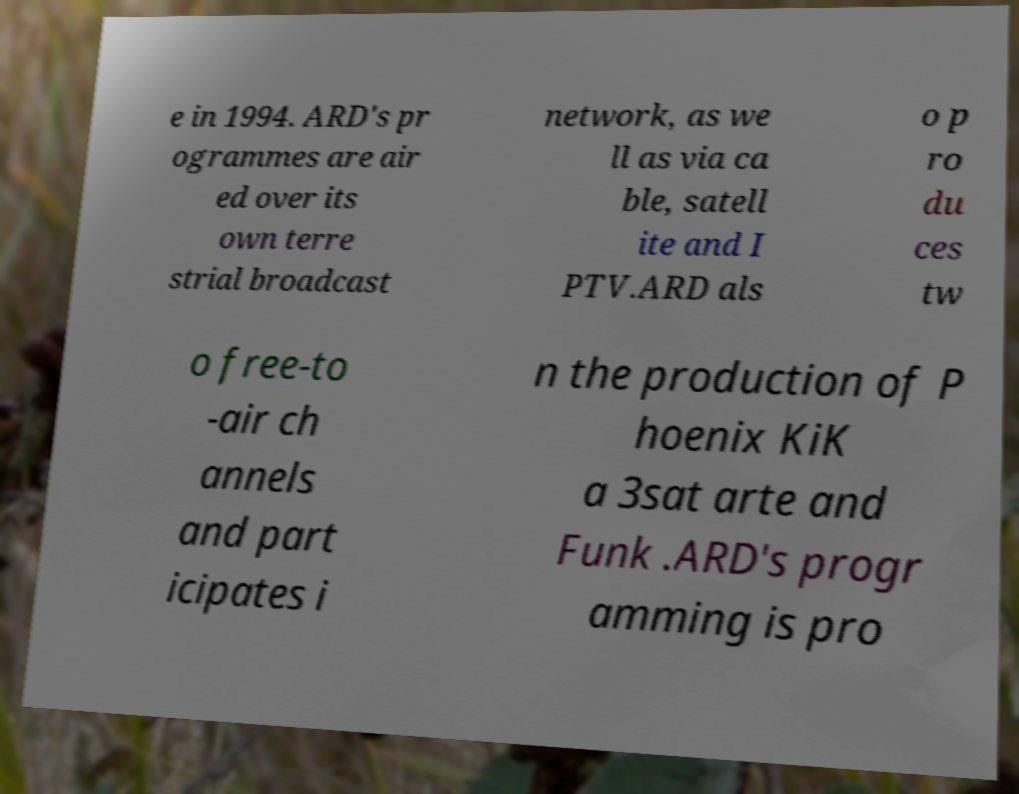Could you extract and type out the text from this image? e in 1994. ARD's pr ogrammes are air ed over its own terre strial broadcast network, as we ll as via ca ble, satell ite and I PTV.ARD als o p ro du ces tw o free-to -air ch annels and part icipates i n the production of P hoenix KiK a 3sat arte and Funk .ARD's progr amming is pro 